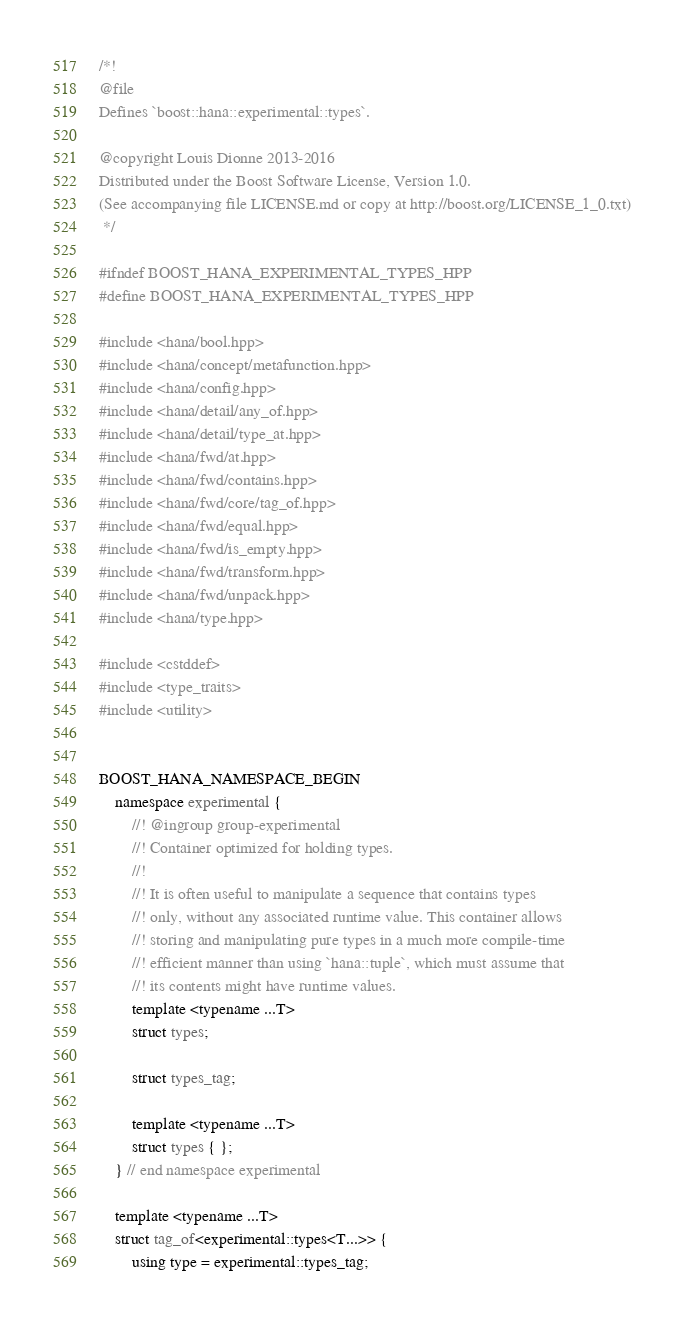Convert code to text. <code><loc_0><loc_0><loc_500><loc_500><_C++_>/*!
@file
Defines `boost::hana::experimental::types`.

@copyright Louis Dionne 2013-2016
Distributed under the Boost Software License, Version 1.0.
(See accompanying file LICENSE.md or copy at http://boost.org/LICENSE_1_0.txt)
 */

#ifndef BOOST_HANA_EXPERIMENTAL_TYPES_HPP
#define BOOST_HANA_EXPERIMENTAL_TYPES_HPP

#include <hana/bool.hpp>
#include <hana/concept/metafunction.hpp>
#include <hana/config.hpp>
#include <hana/detail/any_of.hpp>
#include <hana/detail/type_at.hpp>
#include <hana/fwd/at.hpp>
#include <hana/fwd/contains.hpp>
#include <hana/fwd/core/tag_of.hpp>
#include <hana/fwd/equal.hpp>
#include <hana/fwd/is_empty.hpp>
#include <hana/fwd/transform.hpp>
#include <hana/fwd/unpack.hpp>
#include <hana/type.hpp>

#include <cstddef>
#include <type_traits>
#include <utility>


BOOST_HANA_NAMESPACE_BEGIN
    namespace experimental {
        //! @ingroup group-experimental
        //! Container optimized for holding types.
        //!
        //! It is often useful to manipulate a sequence that contains types
        //! only, without any associated runtime value. This container allows
        //! storing and manipulating pure types in a much more compile-time
        //! efficient manner than using `hana::tuple`, which must assume that
        //! its contents might have runtime values.
        template <typename ...T>
        struct types;

        struct types_tag;

        template <typename ...T>
        struct types { };
    } // end namespace experimental

    template <typename ...T>
    struct tag_of<experimental::types<T...>> {
        using type = experimental::types_tag;</code> 